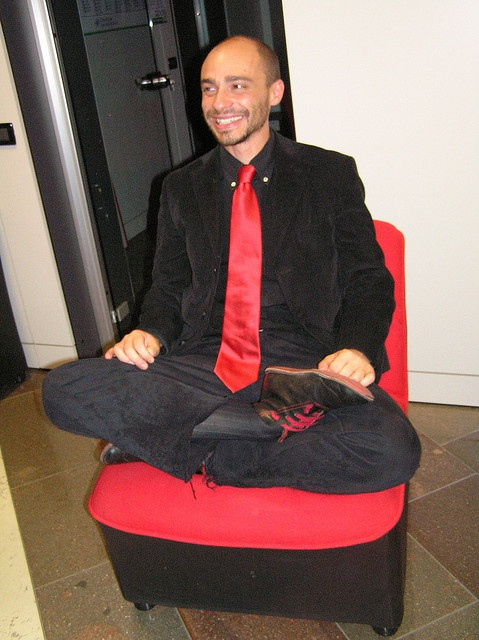Describe the objects in this image and their specific colors. I can see people in black, gray, and salmon tones, chair in black, salmon, and red tones, and tie in black, salmon, and red tones in this image. 